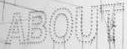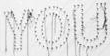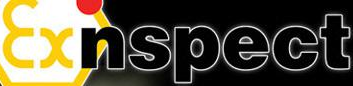Transcribe the words shown in these images in order, separated by a semicolon. ABOUT; YOU; Exnspect 